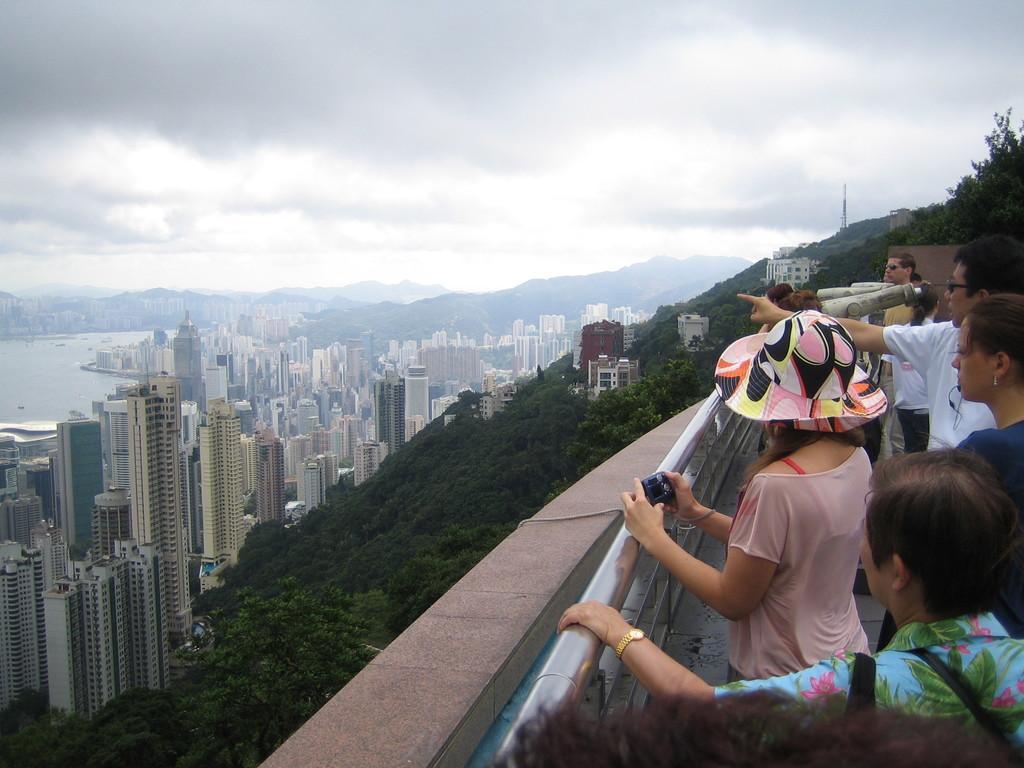Please provide a concise description of this image. On the right side of the image, we can see a group of people are standing near the railings. Here a woman is holding a camera and wearing a hat. Background we can see so many trees, buildings, hills, water and cloudy sky. 